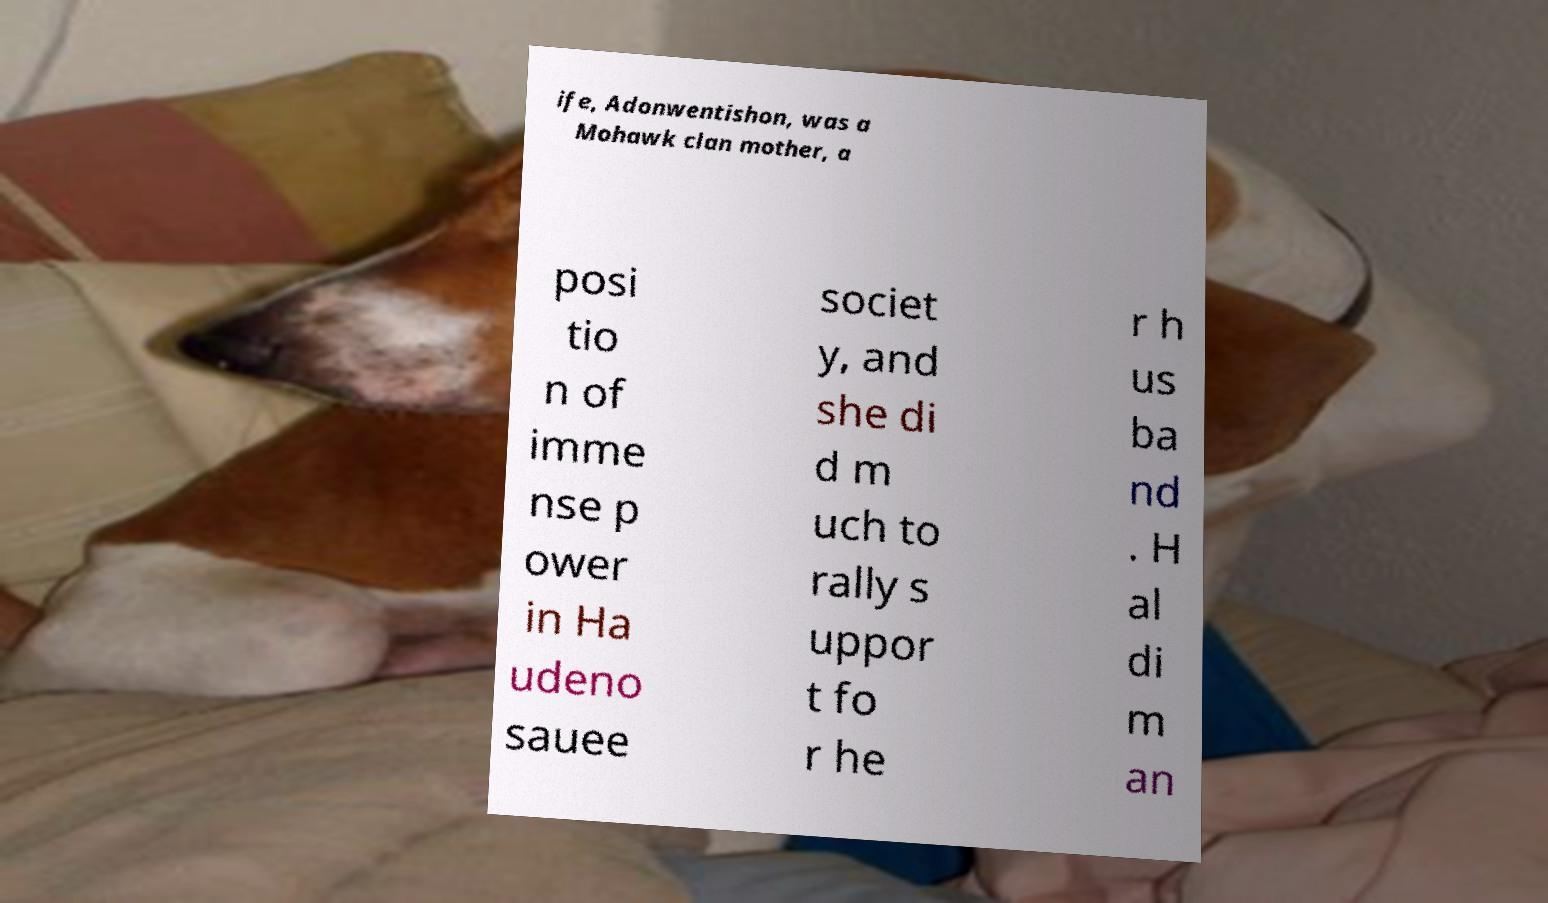Please identify and transcribe the text found in this image. ife, Adonwentishon, was a Mohawk clan mother, a posi tio n of imme nse p ower in Ha udeno sauee societ y, and she di d m uch to rally s uppor t fo r he r h us ba nd . H al di m an 